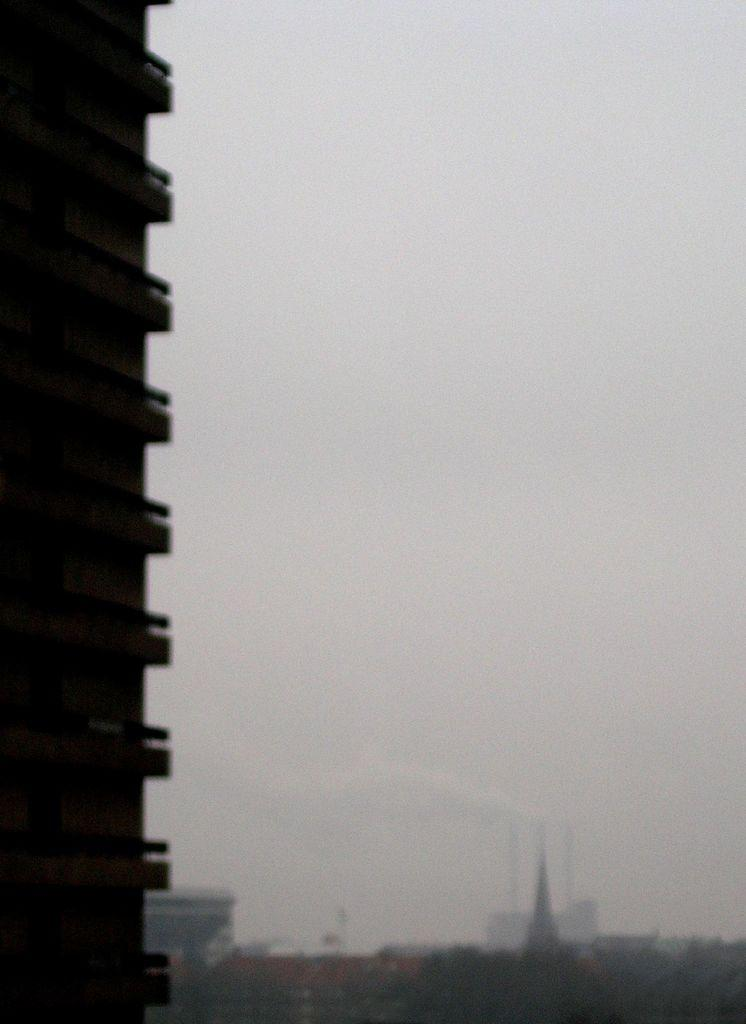What type of structures can be seen in the image? There are a few buildings in the image. Can you describe the appearance of one of the buildings? One building is truncated on the left side of the image. What can be seen in the background of the image? The sky is visible in the background of the image. What type of footwear is visible on the roof of the building in the image? There is no footwear visible on the roof of the building in the image. 